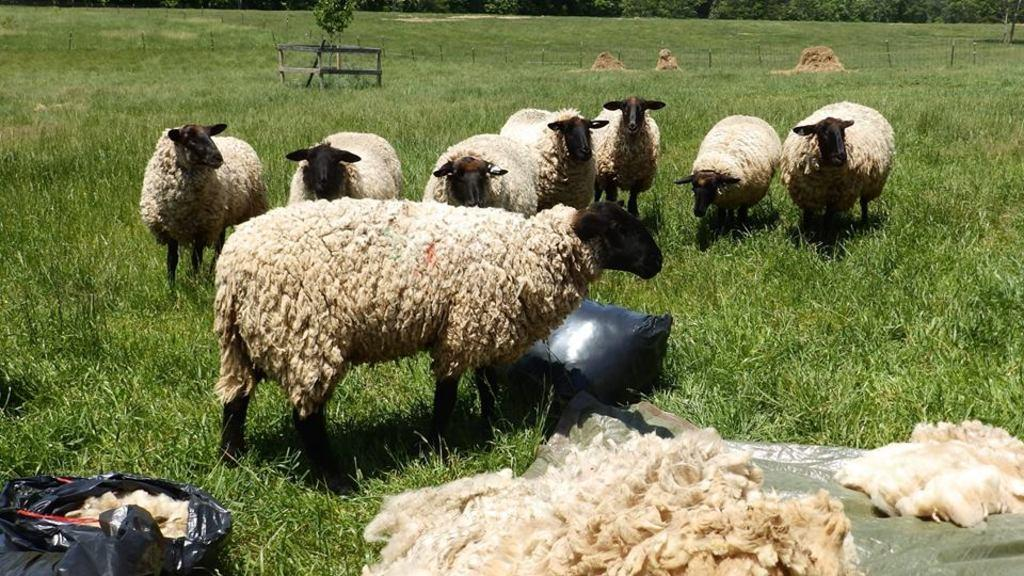What type of material is present in the bags in the image? There are bags of wool in the image. What animals can be seen in the image? There is a herd of sheep in the image. What type of vegetation is visible in the background of the image? There is grass and plants in the background of the image. How many kilometers of border does the herd of sheep protect in the image? There is no information about borders or the sheep's protective role in the image. The image simply shows a herd of sheep and bags of wool. What scientific theory is being demonstrated by the sheep in the image? There is no scientific theory being demonstrated by the sheep in the image. The image simply shows a herd of sheep and bags of wool. 